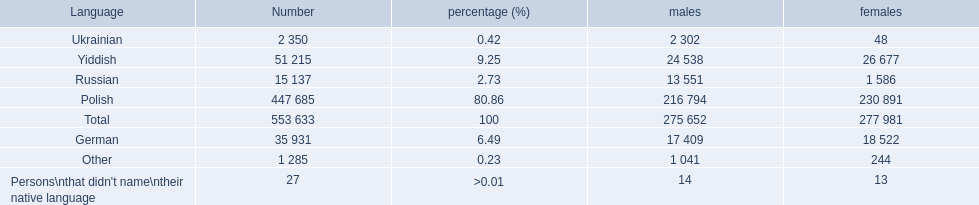What are all of the languages? Polish, Yiddish, German, Russian, Ukrainian, Other, Persons\nthat didn't name\ntheir native language. And how many people speak these languages? 447 685, 51 215, 35 931, 15 137, 2 350, 1 285, 27. Which language is used by most people? Polish. 